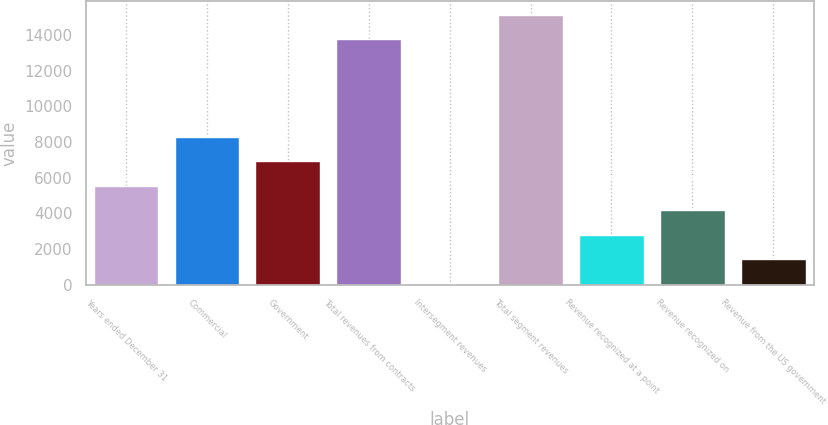Convert chart to OTSL. <chart><loc_0><loc_0><loc_500><loc_500><bar_chart><fcel>Years ended December 31<fcel>Commercial<fcel>Government<fcel>Total revenues from contracts<fcel>Intersegment revenues<fcel>Total segment revenues<fcel>Revenue recognized at a point<fcel>Revenue recognized on<fcel>Revenue from the US government<nl><fcel>5552.2<fcel>8307.8<fcel>6930<fcel>13778<fcel>41<fcel>15155.8<fcel>2796.6<fcel>4174.4<fcel>1418.8<nl></chart> 